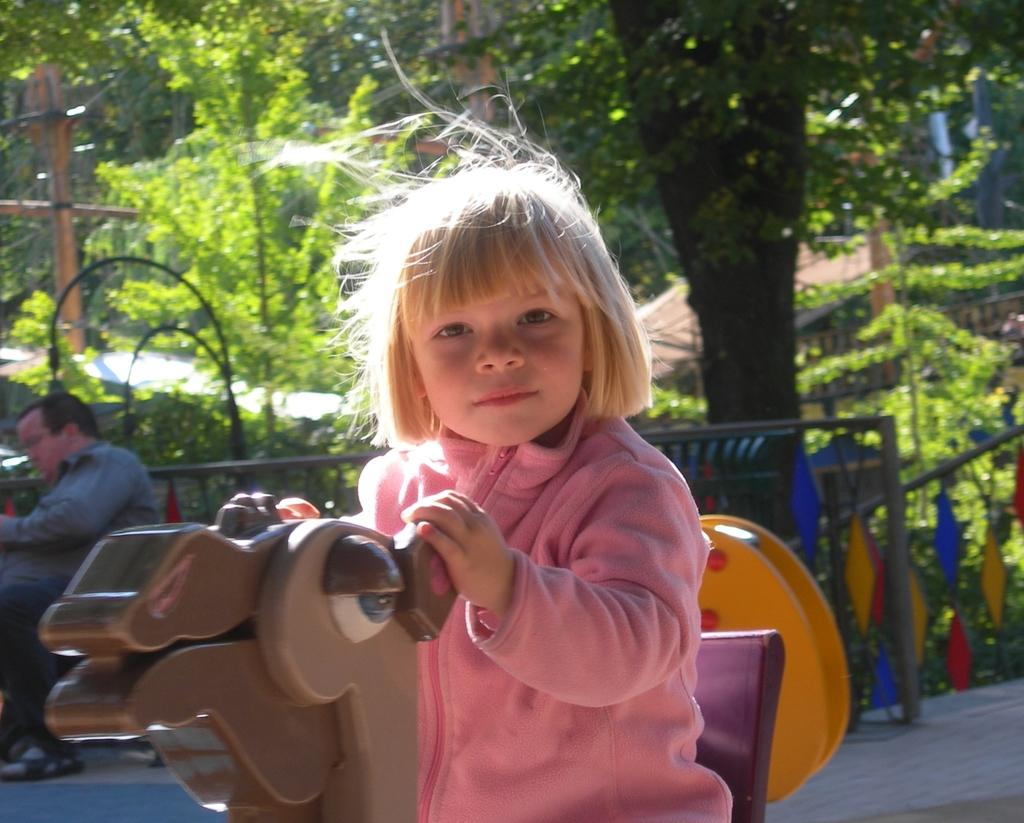What is the kid doing in the image? The kid is sitting on a toy horse in the image. Can you describe the person in the background of the image? There is a person sitting on a bench in the background of the image. What can be seen in the background of the image besides the person? There are trees, a pole, and plants in the background of the image. When was the image taken? The image was taken during the day. What type of coil is wrapped around the kid's leg in the image? There is no coil wrapped around the kid's leg in the image. What kind of bean is growing on the toy horse in the image? There are no beans present in the image, as it features a kid sitting on a toy horse and a person sitting on a bench in the background. 